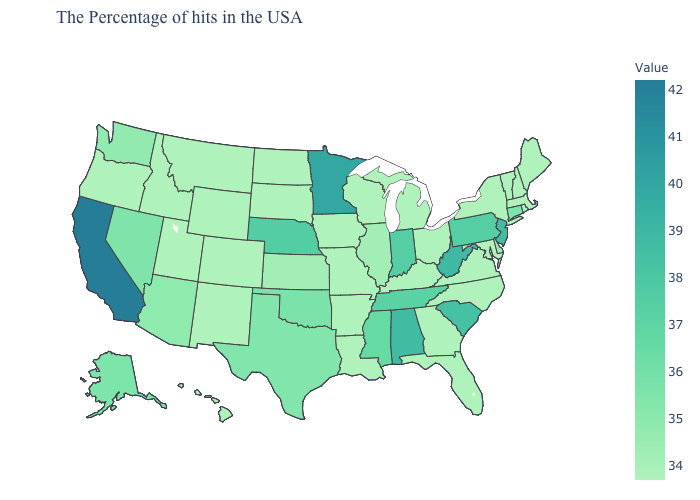Is the legend a continuous bar?
Give a very brief answer. Yes. Does Utah have a higher value than Nevada?
Quick response, please. No. Is the legend a continuous bar?
Give a very brief answer. Yes. 